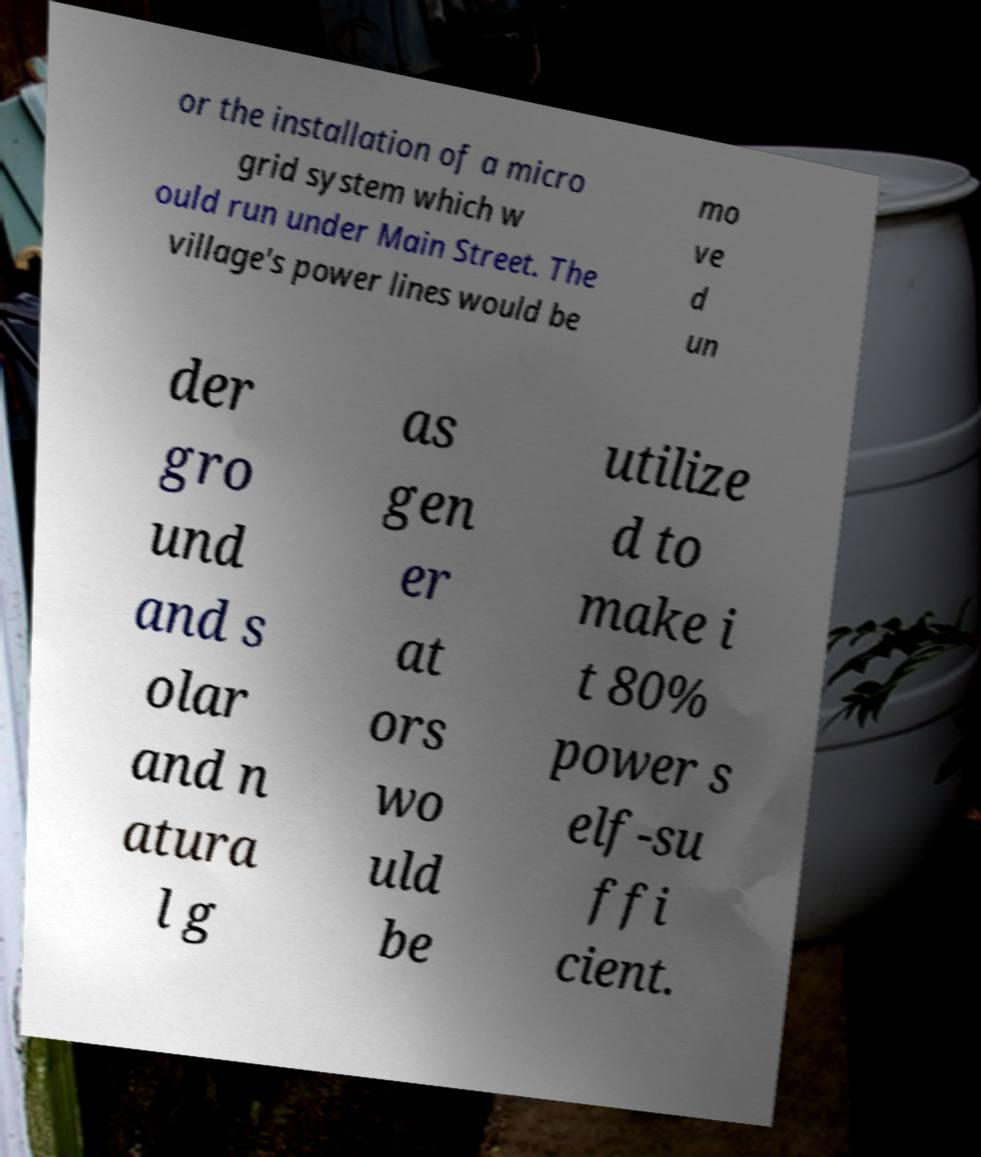Can you read and provide the text displayed in the image?This photo seems to have some interesting text. Can you extract and type it out for me? or the installation of a micro grid system which w ould run under Main Street. The village's power lines would be mo ve d un der gro und and s olar and n atura l g as gen er at ors wo uld be utilize d to make i t 80% power s elf-su ffi cient. 